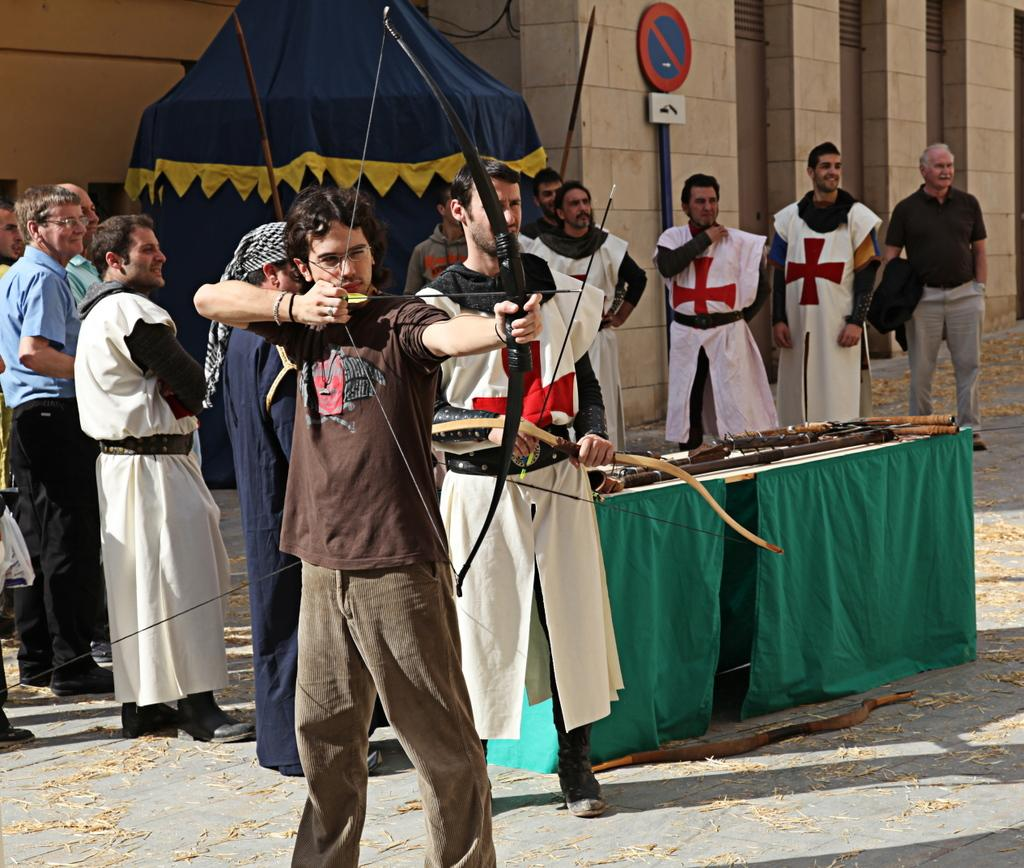What are the people in the image doing? The people in the image are standing on the road. Are there any animals present in the image? Yes, there are cows on a table in the image. Can you describe the man in the image? The man in the image is standing and holding a bow and arrow in his hand. What time of day is it in the image, based on the hour? The provided facts do not mention the time of day or any hour. How many kittens are playing with the cows on the table? There are no kittens present in the image. What is the process of digestion for the cows in the image? The process of digestion for the cows in the image is not visible or describable based on the provided facts. 